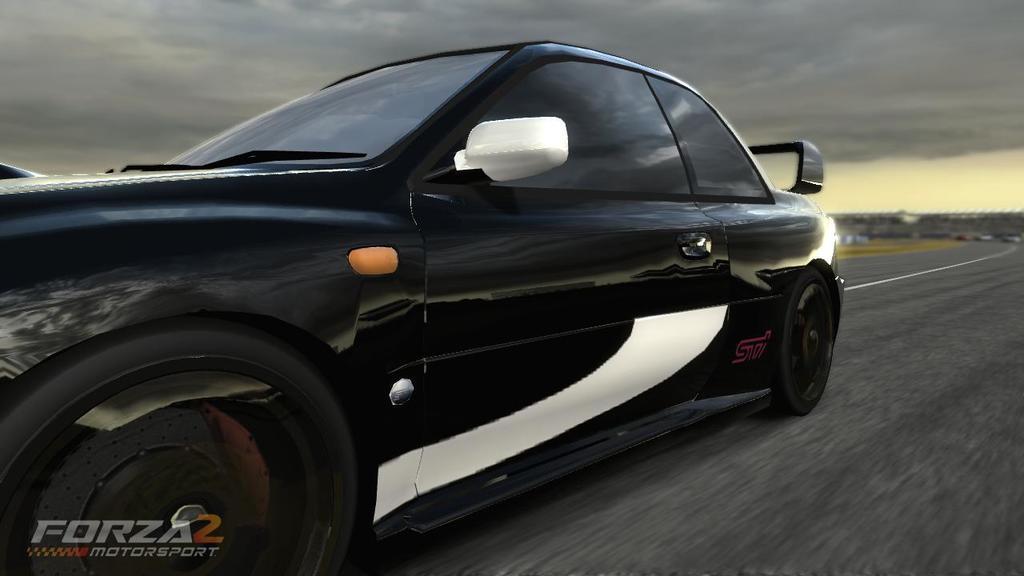Please provide a concise description of this image. In this image in the center there is one car and at the bottom there is road, and in the background there is grass and at the top there is sky. 